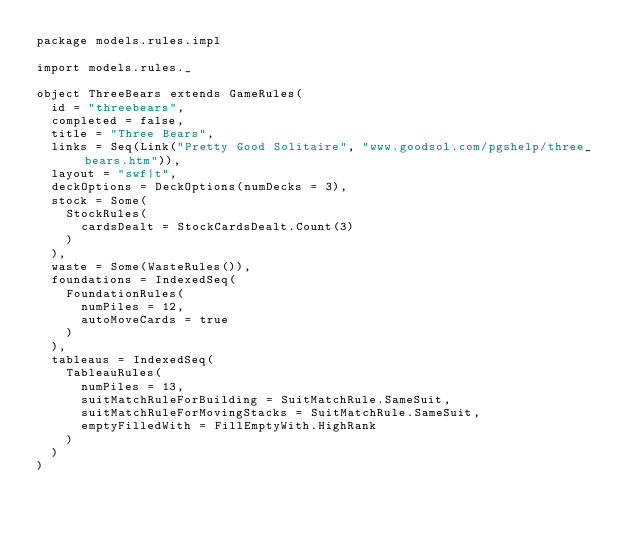<code> <loc_0><loc_0><loc_500><loc_500><_Scala_>package models.rules.impl

import models.rules._

object ThreeBears extends GameRules(
  id = "threebears",
  completed = false,
  title = "Three Bears",
  links = Seq(Link("Pretty Good Solitaire", "www.goodsol.com/pgshelp/three_bears.htm")),
  layout = "swf|t",
  deckOptions = DeckOptions(numDecks = 3),
  stock = Some(
    StockRules(
      cardsDealt = StockCardsDealt.Count(3)
    )
  ),
  waste = Some(WasteRules()),
  foundations = IndexedSeq(
    FoundationRules(
      numPiles = 12,
      autoMoveCards = true
    )
  ),
  tableaus = IndexedSeq(
    TableauRules(
      numPiles = 13,
      suitMatchRuleForBuilding = SuitMatchRule.SameSuit,
      suitMatchRuleForMovingStacks = SuitMatchRule.SameSuit,
      emptyFilledWith = FillEmptyWith.HighRank
    )
  )
)
</code> 